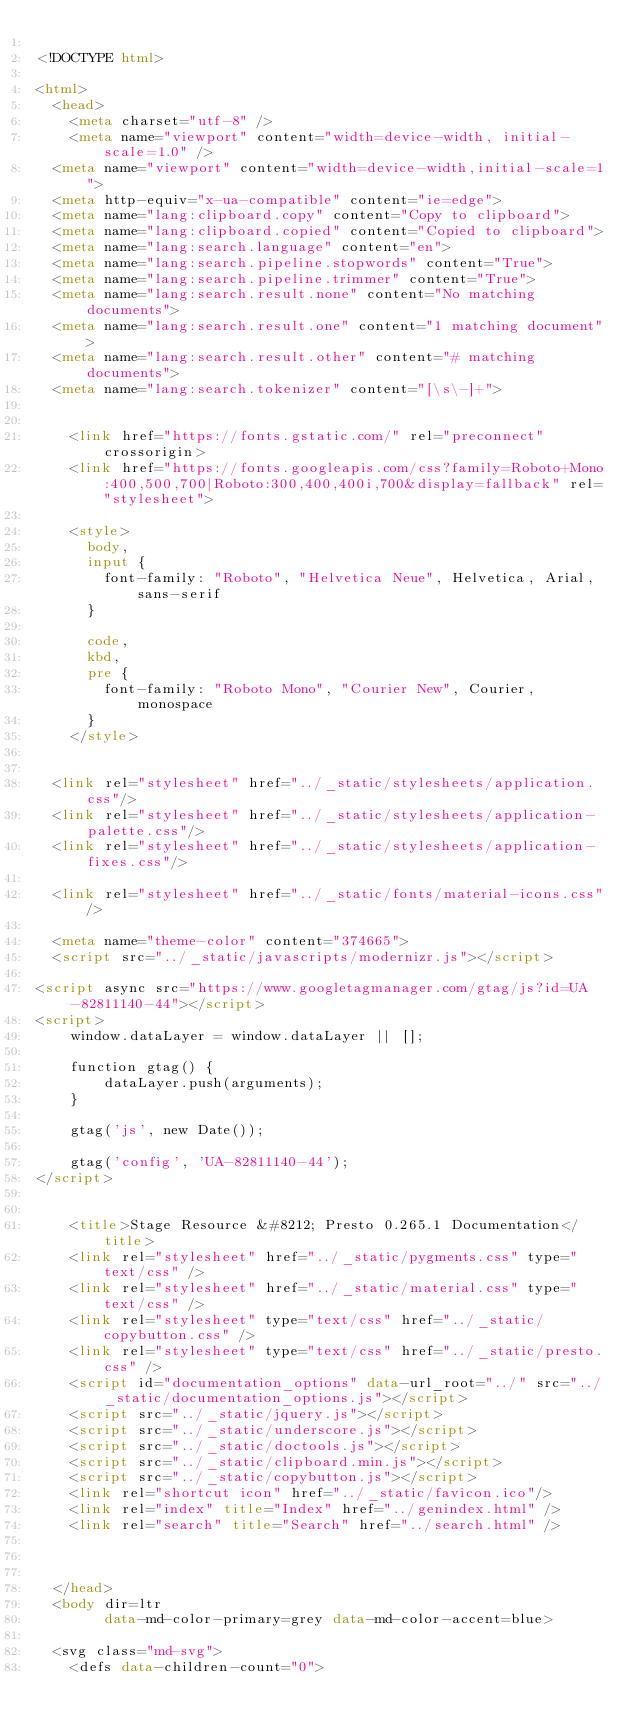<code> <loc_0><loc_0><loc_500><loc_500><_HTML_>
<!DOCTYPE html>

<html>
  <head>
    <meta charset="utf-8" />
    <meta name="viewport" content="width=device-width, initial-scale=1.0" />
  <meta name="viewport" content="width=device-width,initial-scale=1">
  <meta http-equiv="x-ua-compatible" content="ie=edge">
  <meta name="lang:clipboard.copy" content="Copy to clipboard">
  <meta name="lang:clipboard.copied" content="Copied to clipboard">
  <meta name="lang:search.language" content="en">
  <meta name="lang:search.pipeline.stopwords" content="True">
  <meta name="lang:search.pipeline.trimmer" content="True">
  <meta name="lang:search.result.none" content="No matching documents">
  <meta name="lang:search.result.one" content="1 matching document">
  <meta name="lang:search.result.other" content="# matching documents">
  <meta name="lang:search.tokenizer" content="[\s\-]+">

  
    <link href="https://fonts.gstatic.com/" rel="preconnect" crossorigin>
    <link href="https://fonts.googleapis.com/css?family=Roboto+Mono:400,500,700|Roboto:300,400,400i,700&display=fallback" rel="stylesheet">

    <style>
      body,
      input {
        font-family: "Roboto", "Helvetica Neue", Helvetica, Arial, sans-serif
      }

      code,
      kbd,
      pre {
        font-family: "Roboto Mono", "Courier New", Courier, monospace
      }
    </style>
  

  <link rel="stylesheet" href="../_static/stylesheets/application.css"/>
  <link rel="stylesheet" href="../_static/stylesheets/application-palette.css"/>
  <link rel="stylesheet" href="../_static/stylesheets/application-fixes.css"/>
  
  <link rel="stylesheet" href="../_static/fonts/material-icons.css"/>
  
  <meta name="theme-color" content="374665">
  <script src="../_static/javascripts/modernizr.js"></script>
  
<script async src="https://www.googletagmanager.com/gtag/js?id=UA-82811140-44"></script>
<script>
    window.dataLayer = window.dataLayer || [];

    function gtag() {
        dataLayer.push(arguments);
    }

    gtag('js', new Date());

    gtag('config', 'UA-82811140-44');
</script>
  
  
    <title>Stage Resource &#8212; Presto 0.265.1 Documentation</title>
    <link rel="stylesheet" href="../_static/pygments.css" type="text/css" />
    <link rel="stylesheet" href="../_static/material.css" type="text/css" />
    <link rel="stylesheet" type="text/css" href="../_static/copybutton.css" />
    <link rel="stylesheet" type="text/css" href="../_static/presto.css" />
    <script id="documentation_options" data-url_root="../" src="../_static/documentation_options.js"></script>
    <script src="../_static/jquery.js"></script>
    <script src="../_static/underscore.js"></script>
    <script src="../_static/doctools.js"></script>
    <script src="../_static/clipboard.min.js"></script>
    <script src="../_static/copybutton.js"></script>
    <link rel="shortcut icon" href="../_static/favicon.ico"/>
    <link rel="index" title="Index" href="../genindex.html" />
    <link rel="search" title="Search" href="../search.html" />
  
   

  </head>
  <body dir=ltr
        data-md-color-primary=grey data-md-color-accent=blue>
  
  <svg class="md-svg">
    <defs data-children-count="0">
      </code> 